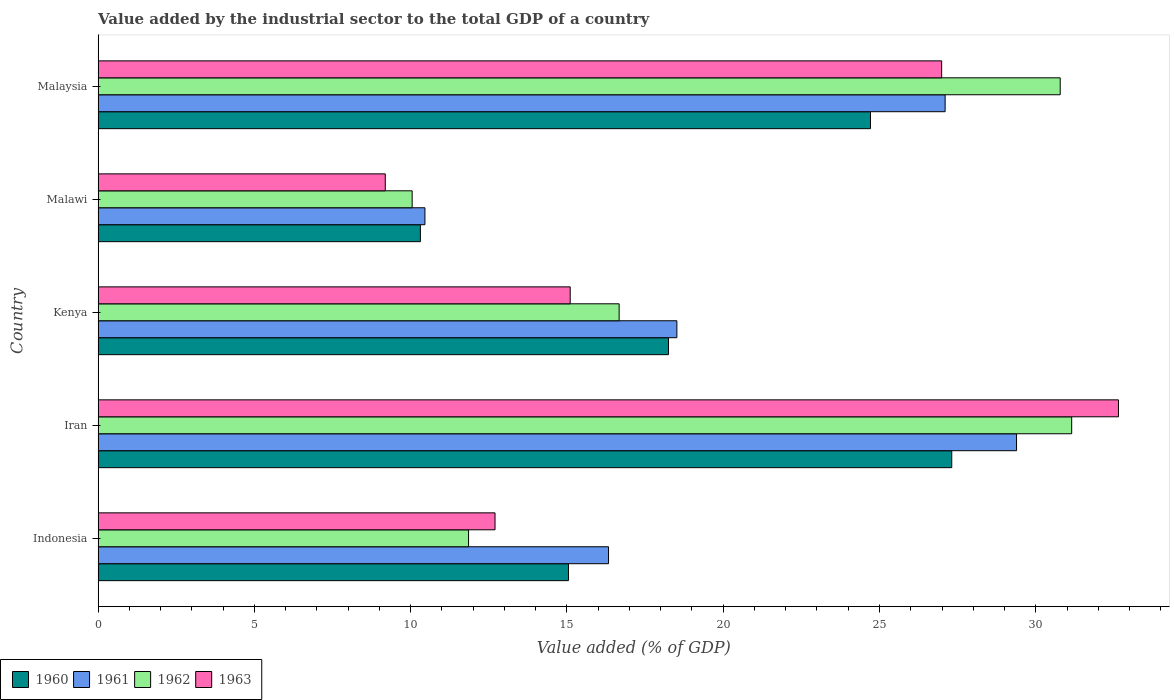How many different coloured bars are there?
Keep it short and to the point. 4. How many groups of bars are there?
Offer a terse response. 5. Are the number of bars on each tick of the Y-axis equal?
Give a very brief answer. Yes. How many bars are there on the 4th tick from the bottom?
Make the answer very short. 4. What is the label of the 1st group of bars from the top?
Keep it short and to the point. Malaysia. What is the value added by the industrial sector to the total GDP in 1960 in Iran?
Offer a terse response. 27.31. Across all countries, what is the maximum value added by the industrial sector to the total GDP in 1962?
Offer a very short reply. 31.15. Across all countries, what is the minimum value added by the industrial sector to the total GDP in 1960?
Keep it short and to the point. 10.31. In which country was the value added by the industrial sector to the total GDP in 1961 maximum?
Make the answer very short. Iran. In which country was the value added by the industrial sector to the total GDP in 1960 minimum?
Offer a very short reply. Malawi. What is the total value added by the industrial sector to the total GDP in 1960 in the graph?
Your answer should be very brief. 95.63. What is the difference between the value added by the industrial sector to the total GDP in 1963 in Iran and that in Malawi?
Offer a terse response. 23.46. What is the difference between the value added by the industrial sector to the total GDP in 1961 in Iran and the value added by the industrial sector to the total GDP in 1962 in Indonesia?
Provide a succinct answer. 17.53. What is the average value added by the industrial sector to the total GDP in 1961 per country?
Your response must be concise. 20.36. What is the difference between the value added by the industrial sector to the total GDP in 1961 and value added by the industrial sector to the total GDP in 1963 in Kenya?
Ensure brevity in your answer.  3.41. In how many countries, is the value added by the industrial sector to the total GDP in 1961 greater than 3 %?
Ensure brevity in your answer.  5. What is the ratio of the value added by the industrial sector to the total GDP in 1961 in Indonesia to that in Kenya?
Give a very brief answer. 0.88. Is the difference between the value added by the industrial sector to the total GDP in 1961 in Malawi and Malaysia greater than the difference between the value added by the industrial sector to the total GDP in 1963 in Malawi and Malaysia?
Make the answer very short. Yes. What is the difference between the highest and the second highest value added by the industrial sector to the total GDP in 1961?
Your answer should be very brief. 2.29. What is the difference between the highest and the lowest value added by the industrial sector to the total GDP in 1960?
Keep it short and to the point. 17. Is the sum of the value added by the industrial sector to the total GDP in 1962 in Indonesia and Iran greater than the maximum value added by the industrial sector to the total GDP in 1960 across all countries?
Ensure brevity in your answer.  Yes. Is it the case that in every country, the sum of the value added by the industrial sector to the total GDP in 1961 and value added by the industrial sector to the total GDP in 1963 is greater than the sum of value added by the industrial sector to the total GDP in 1962 and value added by the industrial sector to the total GDP in 1960?
Ensure brevity in your answer.  No. What does the 3rd bar from the bottom in Malaysia represents?
Provide a succinct answer. 1962. How many countries are there in the graph?
Give a very brief answer. 5. What is the difference between two consecutive major ticks on the X-axis?
Your answer should be compact. 5. Does the graph contain any zero values?
Your answer should be compact. No. How many legend labels are there?
Offer a terse response. 4. How are the legend labels stacked?
Give a very brief answer. Horizontal. What is the title of the graph?
Keep it short and to the point. Value added by the industrial sector to the total GDP of a country. What is the label or title of the X-axis?
Give a very brief answer. Value added (% of GDP). What is the Value added (% of GDP) of 1960 in Indonesia?
Make the answer very short. 15.05. What is the Value added (% of GDP) in 1961 in Indonesia?
Offer a terse response. 16.33. What is the Value added (% of GDP) of 1962 in Indonesia?
Give a very brief answer. 11.85. What is the Value added (% of GDP) in 1963 in Indonesia?
Make the answer very short. 12.7. What is the Value added (% of GDP) in 1960 in Iran?
Provide a succinct answer. 27.31. What is the Value added (% of GDP) of 1961 in Iran?
Your answer should be very brief. 29.38. What is the Value added (% of GDP) in 1962 in Iran?
Your answer should be very brief. 31.15. What is the Value added (% of GDP) of 1963 in Iran?
Provide a short and direct response. 32.65. What is the Value added (% of GDP) of 1960 in Kenya?
Make the answer very short. 18.25. What is the Value added (% of GDP) in 1961 in Kenya?
Your answer should be very brief. 18.52. What is the Value added (% of GDP) of 1962 in Kenya?
Give a very brief answer. 16.67. What is the Value added (% of GDP) of 1963 in Kenya?
Your response must be concise. 15.1. What is the Value added (% of GDP) in 1960 in Malawi?
Provide a short and direct response. 10.31. What is the Value added (% of GDP) of 1961 in Malawi?
Make the answer very short. 10.46. What is the Value added (% of GDP) in 1962 in Malawi?
Offer a very short reply. 10.05. What is the Value added (% of GDP) of 1963 in Malawi?
Offer a terse response. 9.19. What is the Value added (% of GDP) of 1960 in Malaysia?
Your answer should be compact. 24.71. What is the Value added (% of GDP) of 1961 in Malaysia?
Your answer should be very brief. 27.1. What is the Value added (% of GDP) in 1962 in Malaysia?
Your response must be concise. 30.78. What is the Value added (% of GDP) in 1963 in Malaysia?
Your answer should be compact. 26.99. Across all countries, what is the maximum Value added (% of GDP) in 1960?
Give a very brief answer. 27.31. Across all countries, what is the maximum Value added (% of GDP) in 1961?
Your answer should be compact. 29.38. Across all countries, what is the maximum Value added (% of GDP) in 1962?
Your response must be concise. 31.15. Across all countries, what is the maximum Value added (% of GDP) in 1963?
Give a very brief answer. 32.65. Across all countries, what is the minimum Value added (% of GDP) in 1960?
Keep it short and to the point. 10.31. Across all countries, what is the minimum Value added (% of GDP) in 1961?
Offer a very short reply. 10.46. Across all countries, what is the minimum Value added (% of GDP) in 1962?
Offer a terse response. 10.05. Across all countries, what is the minimum Value added (% of GDP) of 1963?
Give a very brief answer. 9.19. What is the total Value added (% of GDP) in 1960 in the graph?
Give a very brief answer. 95.63. What is the total Value added (% of GDP) of 1961 in the graph?
Ensure brevity in your answer.  101.79. What is the total Value added (% of GDP) of 1962 in the graph?
Your response must be concise. 100.5. What is the total Value added (% of GDP) in 1963 in the graph?
Offer a very short reply. 96.63. What is the difference between the Value added (% of GDP) of 1960 in Indonesia and that in Iran?
Give a very brief answer. -12.26. What is the difference between the Value added (% of GDP) of 1961 in Indonesia and that in Iran?
Make the answer very short. -13.05. What is the difference between the Value added (% of GDP) of 1962 in Indonesia and that in Iran?
Provide a succinct answer. -19.3. What is the difference between the Value added (% of GDP) of 1963 in Indonesia and that in Iran?
Offer a terse response. -19.95. What is the difference between the Value added (% of GDP) of 1960 in Indonesia and that in Kenya?
Ensure brevity in your answer.  -3.2. What is the difference between the Value added (% of GDP) in 1961 in Indonesia and that in Kenya?
Your response must be concise. -2.19. What is the difference between the Value added (% of GDP) of 1962 in Indonesia and that in Kenya?
Your response must be concise. -4.82. What is the difference between the Value added (% of GDP) of 1963 in Indonesia and that in Kenya?
Offer a very short reply. -2.4. What is the difference between the Value added (% of GDP) in 1960 in Indonesia and that in Malawi?
Your answer should be compact. 4.74. What is the difference between the Value added (% of GDP) in 1961 in Indonesia and that in Malawi?
Provide a succinct answer. 5.87. What is the difference between the Value added (% of GDP) in 1962 in Indonesia and that in Malawi?
Your answer should be compact. 1.8. What is the difference between the Value added (% of GDP) in 1963 in Indonesia and that in Malawi?
Make the answer very short. 3.51. What is the difference between the Value added (% of GDP) in 1960 in Indonesia and that in Malaysia?
Make the answer very short. -9.66. What is the difference between the Value added (% of GDP) in 1961 in Indonesia and that in Malaysia?
Your response must be concise. -10.77. What is the difference between the Value added (% of GDP) of 1962 in Indonesia and that in Malaysia?
Your answer should be compact. -18.93. What is the difference between the Value added (% of GDP) of 1963 in Indonesia and that in Malaysia?
Give a very brief answer. -14.29. What is the difference between the Value added (% of GDP) of 1960 in Iran and that in Kenya?
Offer a very short reply. 9.06. What is the difference between the Value added (% of GDP) of 1961 in Iran and that in Kenya?
Your answer should be very brief. 10.87. What is the difference between the Value added (% of GDP) in 1962 in Iran and that in Kenya?
Give a very brief answer. 14.48. What is the difference between the Value added (% of GDP) in 1963 in Iran and that in Kenya?
Keep it short and to the point. 17.54. What is the difference between the Value added (% of GDP) of 1960 in Iran and that in Malawi?
Offer a very short reply. 17. What is the difference between the Value added (% of GDP) in 1961 in Iran and that in Malawi?
Your response must be concise. 18.93. What is the difference between the Value added (% of GDP) of 1962 in Iran and that in Malawi?
Give a very brief answer. 21.1. What is the difference between the Value added (% of GDP) of 1963 in Iran and that in Malawi?
Make the answer very short. 23.46. What is the difference between the Value added (% of GDP) in 1960 in Iran and that in Malaysia?
Provide a succinct answer. 2.6. What is the difference between the Value added (% of GDP) of 1961 in Iran and that in Malaysia?
Give a very brief answer. 2.29. What is the difference between the Value added (% of GDP) in 1962 in Iran and that in Malaysia?
Provide a succinct answer. 0.37. What is the difference between the Value added (% of GDP) in 1963 in Iran and that in Malaysia?
Your answer should be very brief. 5.66. What is the difference between the Value added (% of GDP) in 1960 in Kenya and that in Malawi?
Offer a terse response. 7.94. What is the difference between the Value added (% of GDP) of 1961 in Kenya and that in Malawi?
Ensure brevity in your answer.  8.06. What is the difference between the Value added (% of GDP) in 1962 in Kenya and that in Malawi?
Provide a short and direct response. 6.62. What is the difference between the Value added (% of GDP) in 1963 in Kenya and that in Malawi?
Your answer should be compact. 5.92. What is the difference between the Value added (% of GDP) in 1960 in Kenya and that in Malaysia?
Your response must be concise. -6.46. What is the difference between the Value added (% of GDP) in 1961 in Kenya and that in Malaysia?
Provide a short and direct response. -8.58. What is the difference between the Value added (% of GDP) of 1962 in Kenya and that in Malaysia?
Provide a succinct answer. -14.11. What is the difference between the Value added (% of GDP) of 1963 in Kenya and that in Malaysia?
Your response must be concise. -11.88. What is the difference between the Value added (% of GDP) in 1960 in Malawi and that in Malaysia?
Your response must be concise. -14.4. What is the difference between the Value added (% of GDP) in 1961 in Malawi and that in Malaysia?
Keep it short and to the point. -16.64. What is the difference between the Value added (% of GDP) in 1962 in Malawi and that in Malaysia?
Provide a short and direct response. -20.73. What is the difference between the Value added (% of GDP) of 1963 in Malawi and that in Malaysia?
Ensure brevity in your answer.  -17.8. What is the difference between the Value added (% of GDP) in 1960 in Indonesia and the Value added (% of GDP) in 1961 in Iran?
Keep it short and to the point. -14.34. What is the difference between the Value added (% of GDP) in 1960 in Indonesia and the Value added (% of GDP) in 1962 in Iran?
Keep it short and to the point. -16.1. What is the difference between the Value added (% of GDP) of 1960 in Indonesia and the Value added (% of GDP) of 1963 in Iran?
Your answer should be very brief. -17.6. What is the difference between the Value added (% of GDP) in 1961 in Indonesia and the Value added (% of GDP) in 1962 in Iran?
Offer a terse response. -14.82. What is the difference between the Value added (% of GDP) in 1961 in Indonesia and the Value added (% of GDP) in 1963 in Iran?
Your answer should be very brief. -16.32. What is the difference between the Value added (% of GDP) of 1962 in Indonesia and the Value added (% of GDP) of 1963 in Iran?
Make the answer very short. -20.79. What is the difference between the Value added (% of GDP) of 1960 in Indonesia and the Value added (% of GDP) of 1961 in Kenya?
Your answer should be compact. -3.47. What is the difference between the Value added (% of GDP) of 1960 in Indonesia and the Value added (% of GDP) of 1962 in Kenya?
Provide a succinct answer. -1.62. What is the difference between the Value added (% of GDP) of 1960 in Indonesia and the Value added (% of GDP) of 1963 in Kenya?
Give a very brief answer. -0.06. What is the difference between the Value added (% of GDP) in 1961 in Indonesia and the Value added (% of GDP) in 1962 in Kenya?
Give a very brief answer. -0.34. What is the difference between the Value added (% of GDP) in 1961 in Indonesia and the Value added (% of GDP) in 1963 in Kenya?
Your answer should be compact. 1.23. What is the difference between the Value added (% of GDP) of 1962 in Indonesia and the Value added (% of GDP) of 1963 in Kenya?
Ensure brevity in your answer.  -3.25. What is the difference between the Value added (% of GDP) of 1960 in Indonesia and the Value added (% of GDP) of 1961 in Malawi?
Give a very brief answer. 4.59. What is the difference between the Value added (% of GDP) in 1960 in Indonesia and the Value added (% of GDP) in 1962 in Malawi?
Your response must be concise. 5. What is the difference between the Value added (% of GDP) in 1960 in Indonesia and the Value added (% of GDP) in 1963 in Malawi?
Make the answer very short. 5.86. What is the difference between the Value added (% of GDP) in 1961 in Indonesia and the Value added (% of GDP) in 1962 in Malawi?
Keep it short and to the point. 6.28. What is the difference between the Value added (% of GDP) of 1961 in Indonesia and the Value added (% of GDP) of 1963 in Malawi?
Give a very brief answer. 7.14. What is the difference between the Value added (% of GDP) of 1962 in Indonesia and the Value added (% of GDP) of 1963 in Malawi?
Ensure brevity in your answer.  2.66. What is the difference between the Value added (% of GDP) of 1960 in Indonesia and the Value added (% of GDP) of 1961 in Malaysia?
Your answer should be compact. -12.05. What is the difference between the Value added (% of GDP) of 1960 in Indonesia and the Value added (% of GDP) of 1962 in Malaysia?
Offer a very short reply. -15.73. What is the difference between the Value added (% of GDP) of 1960 in Indonesia and the Value added (% of GDP) of 1963 in Malaysia?
Your response must be concise. -11.94. What is the difference between the Value added (% of GDP) in 1961 in Indonesia and the Value added (% of GDP) in 1962 in Malaysia?
Offer a very short reply. -14.45. What is the difference between the Value added (% of GDP) of 1961 in Indonesia and the Value added (% of GDP) of 1963 in Malaysia?
Your response must be concise. -10.66. What is the difference between the Value added (% of GDP) of 1962 in Indonesia and the Value added (% of GDP) of 1963 in Malaysia?
Provide a succinct answer. -15.14. What is the difference between the Value added (% of GDP) in 1960 in Iran and the Value added (% of GDP) in 1961 in Kenya?
Give a very brief answer. 8.79. What is the difference between the Value added (% of GDP) in 1960 in Iran and the Value added (% of GDP) in 1962 in Kenya?
Your response must be concise. 10.64. What is the difference between the Value added (% of GDP) in 1960 in Iran and the Value added (% of GDP) in 1963 in Kenya?
Give a very brief answer. 12.21. What is the difference between the Value added (% of GDP) in 1961 in Iran and the Value added (% of GDP) in 1962 in Kenya?
Keep it short and to the point. 12.71. What is the difference between the Value added (% of GDP) in 1961 in Iran and the Value added (% of GDP) in 1963 in Kenya?
Keep it short and to the point. 14.28. What is the difference between the Value added (% of GDP) of 1962 in Iran and the Value added (% of GDP) of 1963 in Kenya?
Make the answer very short. 16.04. What is the difference between the Value added (% of GDP) of 1960 in Iran and the Value added (% of GDP) of 1961 in Malawi?
Your response must be concise. 16.86. What is the difference between the Value added (% of GDP) of 1960 in Iran and the Value added (% of GDP) of 1962 in Malawi?
Keep it short and to the point. 17.26. What is the difference between the Value added (% of GDP) in 1960 in Iran and the Value added (% of GDP) in 1963 in Malawi?
Provide a succinct answer. 18.12. What is the difference between the Value added (% of GDP) in 1961 in Iran and the Value added (% of GDP) in 1962 in Malawi?
Provide a succinct answer. 19.34. What is the difference between the Value added (% of GDP) in 1961 in Iran and the Value added (% of GDP) in 1963 in Malawi?
Make the answer very short. 20.2. What is the difference between the Value added (% of GDP) of 1962 in Iran and the Value added (% of GDP) of 1963 in Malawi?
Keep it short and to the point. 21.96. What is the difference between the Value added (% of GDP) of 1960 in Iran and the Value added (% of GDP) of 1961 in Malaysia?
Provide a short and direct response. 0.21. What is the difference between the Value added (% of GDP) of 1960 in Iran and the Value added (% of GDP) of 1962 in Malaysia?
Give a very brief answer. -3.47. What is the difference between the Value added (% of GDP) in 1960 in Iran and the Value added (% of GDP) in 1963 in Malaysia?
Your answer should be compact. 0.32. What is the difference between the Value added (% of GDP) in 1961 in Iran and the Value added (% of GDP) in 1962 in Malaysia?
Offer a very short reply. -1.4. What is the difference between the Value added (% of GDP) in 1961 in Iran and the Value added (% of GDP) in 1963 in Malaysia?
Your answer should be very brief. 2.4. What is the difference between the Value added (% of GDP) in 1962 in Iran and the Value added (% of GDP) in 1963 in Malaysia?
Your answer should be very brief. 4.16. What is the difference between the Value added (% of GDP) in 1960 in Kenya and the Value added (% of GDP) in 1961 in Malawi?
Your answer should be very brief. 7.79. What is the difference between the Value added (% of GDP) of 1960 in Kenya and the Value added (% of GDP) of 1962 in Malawi?
Make the answer very short. 8.2. What is the difference between the Value added (% of GDP) in 1960 in Kenya and the Value added (% of GDP) in 1963 in Malawi?
Your answer should be compact. 9.06. What is the difference between the Value added (% of GDP) in 1961 in Kenya and the Value added (% of GDP) in 1962 in Malawi?
Ensure brevity in your answer.  8.47. What is the difference between the Value added (% of GDP) in 1961 in Kenya and the Value added (% of GDP) in 1963 in Malawi?
Your answer should be very brief. 9.33. What is the difference between the Value added (% of GDP) in 1962 in Kenya and the Value added (% of GDP) in 1963 in Malawi?
Offer a terse response. 7.48. What is the difference between the Value added (% of GDP) in 1960 in Kenya and the Value added (% of GDP) in 1961 in Malaysia?
Your answer should be compact. -8.85. What is the difference between the Value added (% of GDP) of 1960 in Kenya and the Value added (% of GDP) of 1962 in Malaysia?
Offer a very short reply. -12.53. What is the difference between the Value added (% of GDP) of 1960 in Kenya and the Value added (% of GDP) of 1963 in Malaysia?
Offer a terse response. -8.74. What is the difference between the Value added (% of GDP) in 1961 in Kenya and the Value added (% of GDP) in 1962 in Malaysia?
Offer a very short reply. -12.26. What is the difference between the Value added (% of GDP) in 1961 in Kenya and the Value added (% of GDP) in 1963 in Malaysia?
Offer a very short reply. -8.47. What is the difference between the Value added (% of GDP) in 1962 in Kenya and the Value added (% of GDP) in 1963 in Malaysia?
Your answer should be compact. -10.32. What is the difference between the Value added (% of GDP) of 1960 in Malawi and the Value added (% of GDP) of 1961 in Malaysia?
Offer a very short reply. -16.79. What is the difference between the Value added (% of GDP) in 1960 in Malawi and the Value added (% of GDP) in 1962 in Malaysia?
Provide a short and direct response. -20.47. What is the difference between the Value added (% of GDP) of 1960 in Malawi and the Value added (% of GDP) of 1963 in Malaysia?
Your answer should be very brief. -16.68. What is the difference between the Value added (% of GDP) in 1961 in Malawi and the Value added (% of GDP) in 1962 in Malaysia?
Provide a short and direct response. -20.33. What is the difference between the Value added (% of GDP) of 1961 in Malawi and the Value added (% of GDP) of 1963 in Malaysia?
Your answer should be compact. -16.53. What is the difference between the Value added (% of GDP) of 1962 in Malawi and the Value added (% of GDP) of 1963 in Malaysia?
Make the answer very short. -16.94. What is the average Value added (% of GDP) in 1960 per country?
Provide a succinct answer. 19.13. What is the average Value added (% of GDP) in 1961 per country?
Ensure brevity in your answer.  20.36. What is the average Value added (% of GDP) of 1962 per country?
Keep it short and to the point. 20.1. What is the average Value added (% of GDP) of 1963 per country?
Your answer should be very brief. 19.33. What is the difference between the Value added (% of GDP) of 1960 and Value added (% of GDP) of 1961 in Indonesia?
Ensure brevity in your answer.  -1.28. What is the difference between the Value added (% of GDP) in 1960 and Value added (% of GDP) in 1962 in Indonesia?
Provide a succinct answer. 3.2. What is the difference between the Value added (% of GDP) of 1960 and Value added (% of GDP) of 1963 in Indonesia?
Make the answer very short. 2.35. What is the difference between the Value added (% of GDP) in 1961 and Value added (% of GDP) in 1962 in Indonesia?
Your answer should be very brief. 4.48. What is the difference between the Value added (% of GDP) in 1961 and Value added (% of GDP) in 1963 in Indonesia?
Keep it short and to the point. 3.63. What is the difference between the Value added (% of GDP) in 1962 and Value added (% of GDP) in 1963 in Indonesia?
Your answer should be very brief. -0.85. What is the difference between the Value added (% of GDP) of 1960 and Value added (% of GDP) of 1961 in Iran?
Your answer should be very brief. -2.07. What is the difference between the Value added (% of GDP) of 1960 and Value added (% of GDP) of 1962 in Iran?
Your answer should be very brief. -3.84. What is the difference between the Value added (% of GDP) of 1960 and Value added (% of GDP) of 1963 in Iran?
Give a very brief answer. -5.33. What is the difference between the Value added (% of GDP) of 1961 and Value added (% of GDP) of 1962 in Iran?
Offer a terse response. -1.76. What is the difference between the Value added (% of GDP) of 1961 and Value added (% of GDP) of 1963 in Iran?
Offer a very short reply. -3.26. What is the difference between the Value added (% of GDP) in 1962 and Value added (% of GDP) in 1963 in Iran?
Your answer should be compact. -1.5. What is the difference between the Value added (% of GDP) in 1960 and Value added (% of GDP) in 1961 in Kenya?
Make the answer very short. -0.27. What is the difference between the Value added (% of GDP) in 1960 and Value added (% of GDP) in 1962 in Kenya?
Provide a short and direct response. 1.58. What is the difference between the Value added (% of GDP) of 1960 and Value added (% of GDP) of 1963 in Kenya?
Ensure brevity in your answer.  3.14. What is the difference between the Value added (% of GDP) of 1961 and Value added (% of GDP) of 1962 in Kenya?
Your answer should be very brief. 1.85. What is the difference between the Value added (% of GDP) in 1961 and Value added (% of GDP) in 1963 in Kenya?
Ensure brevity in your answer.  3.41. What is the difference between the Value added (% of GDP) of 1962 and Value added (% of GDP) of 1963 in Kenya?
Keep it short and to the point. 1.57. What is the difference between the Value added (% of GDP) in 1960 and Value added (% of GDP) in 1961 in Malawi?
Ensure brevity in your answer.  -0.15. What is the difference between the Value added (% of GDP) in 1960 and Value added (% of GDP) in 1962 in Malawi?
Offer a very short reply. 0.26. What is the difference between the Value added (% of GDP) of 1960 and Value added (% of GDP) of 1963 in Malawi?
Give a very brief answer. 1.12. What is the difference between the Value added (% of GDP) of 1961 and Value added (% of GDP) of 1962 in Malawi?
Offer a terse response. 0.41. What is the difference between the Value added (% of GDP) of 1961 and Value added (% of GDP) of 1963 in Malawi?
Provide a succinct answer. 1.27. What is the difference between the Value added (% of GDP) in 1962 and Value added (% of GDP) in 1963 in Malawi?
Make the answer very short. 0.86. What is the difference between the Value added (% of GDP) in 1960 and Value added (% of GDP) in 1961 in Malaysia?
Provide a succinct answer. -2.39. What is the difference between the Value added (% of GDP) in 1960 and Value added (% of GDP) in 1962 in Malaysia?
Give a very brief answer. -6.07. What is the difference between the Value added (% of GDP) of 1960 and Value added (% of GDP) of 1963 in Malaysia?
Offer a terse response. -2.28. What is the difference between the Value added (% of GDP) of 1961 and Value added (% of GDP) of 1962 in Malaysia?
Offer a terse response. -3.68. What is the difference between the Value added (% of GDP) of 1961 and Value added (% of GDP) of 1963 in Malaysia?
Offer a very short reply. 0.11. What is the difference between the Value added (% of GDP) in 1962 and Value added (% of GDP) in 1963 in Malaysia?
Your answer should be compact. 3.79. What is the ratio of the Value added (% of GDP) of 1960 in Indonesia to that in Iran?
Your answer should be compact. 0.55. What is the ratio of the Value added (% of GDP) in 1961 in Indonesia to that in Iran?
Your answer should be very brief. 0.56. What is the ratio of the Value added (% of GDP) in 1962 in Indonesia to that in Iran?
Provide a succinct answer. 0.38. What is the ratio of the Value added (% of GDP) in 1963 in Indonesia to that in Iran?
Your answer should be very brief. 0.39. What is the ratio of the Value added (% of GDP) of 1960 in Indonesia to that in Kenya?
Offer a terse response. 0.82. What is the ratio of the Value added (% of GDP) of 1961 in Indonesia to that in Kenya?
Your answer should be compact. 0.88. What is the ratio of the Value added (% of GDP) of 1962 in Indonesia to that in Kenya?
Give a very brief answer. 0.71. What is the ratio of the Value added (% of GDP) in 1963 in Indonesia to that in Kenya?
Keep it short and to the point. 0.84. What is the ratio of the Value added (% of GDP) of 1960 in Indonesia to that in Malawi?
Provide a short and direct response. 1.46. What is the ratio of the Value added (% of GDP) in 1961 in Indonesia to that in Malawi?
Make the answer very short. 1.56. What is the ratio of the Value added (% of GDP) of 1962 in Indonesia to that in Malawi?
Ensure brevity in your answer.  1.18. What is the ratio of the Value added (% of GDP) in 1963 in Indonesia to that in Malawi?
Ensure brevity in your answer.  1.38. What is the ratio of the Value added (% of GDP) in 1960 in Indonesia to that in Malaysia?
Give a very brief answer. 0.61. What is the ratio of the Value added (% of GDP) in 1961 in Indonesia to that in Malaysia?
Give a very brief answer. 0.6. What is the ratio of the Value added (% of GDP) in 1962 in Indonesia to that in Malaysia?
Make the answer very short. 0.39. What is the ratio of the Value added (% of GDP) in 1963 in Indonesia to that in Malaysia?
Provide a short and direct response. 0.47. What is the ratio of the Value added (% of GDP) in 1960 in Iran to that in Kenya?
Your response must be concise. 1.5. What is the ratio of the Value added (% of GDP) in 1961 in Iran to that in Kenya?
Keep it short and to the point. 1.59. What is the ratio of the Value added (% of GDP) in 1962 in Iran to that in Kenya?
Make the answer very short. 1.87. What is the ratio of the Value added (% of GDP) in 1963 in Iran to that in Kenya?
Ensure brevity in your answer.  2.16. What is the ratio of the Value added (% of GDP) in 1960 in Iran to that in Malawi?
Keep it short and to the point. 2.65. What is the ratio of the Value added (% of GDP) of 1961 in Iran to that in Malawi?
Your answer should be very brief. 2.81. What is the ratio of the Value added (% of GDP) of 1962 in Iran to that in Malawi?
Your answer should be compact. 3.1. What is the ratio of the Value added (% of GDP) of 1963 in Iran to that in Malawi?
Make the answer very short. 3.55. What is the ratio of the Value added (% of GDP) in 1960 in Iran to that in Malaysia?
Offer a very short reply. 1.11. What is the ratio of the Value added (% of GDP) in 1961 in Iran to that in Malaysia?
Your response must be concise. 1.08. What is the ratio of the Value added (% of GDP) of 1962 in Iran to that in Malaysia?
Ensure brevity in your answer.  1.01. What is the ratio of the Value added (% of GDP) in 1963 in Iran to that in Malaysia?
Provide a succinct answer. 1.21. What is the ratio of the Value added (% of GDP) in 1960 in Kenya to that in Malawi?
Your answer should be compact. 1.77. What is the ratio of the Value added (% of GDP) in 1961 in Kenya to that in Malawi?
Your answer should be very brief. 1.77. What is the ratio of the Value added (% of GDP) in 1962 in Kenya to that in Malawi?
Provide a short and direct response. 1.66. What is the ratio of the Value added (% of GDP) of 1963 in Kenya to that in Malawi?
Your answer should be compact. 1.64. What is the ratio of the Value added (% of GDP) in 1960 in Kenya to that in Malaysia?
Keep it short and to the point. 0.74. What is the ratio of the Value added (% of GDP) in 1961 in Kenya to that in Malaysia?
Your answer should be compact. 0.68. What is the ratio of the Value added (% of GDP) in 1962 in Kenya to that in Malaysia?
Your response must be concise. 0.54. What is the ratio of the Value added (% of GDP) in 1963 in Kenya to that in Malaysia?
Ensure brevity in your answer.  0.56. What is the ratio of the Value added (% of GDP) in 1960 in Malawi to that in Malaysia?
Your response must be concise. 0.42. What is the ratio of the Value added (% of GDP) in 1961 in Malawi to that in Malaysia?
Make the answer very short. 0.39. What is the ratio of the Value added (% of GDP) in 1962 in Malawi to that in Malaysia?
Ensure brevity in your answer.  0.33. What is the ratio of the Value added (% of GDP) in 1963 in Malawi to that in Malaysia?
Offer a very short reply. 0.34. What is the difference between the highest and the second highest Value added (% of GDP) of 1960?
Your response must be concise. 2.6. What is the difference between the highest and the second highest Value added (% of GDP) in 1961?
Your response must be concise. 2.29. What is the difference between the highest and the second highest Value added (% of GDP) in 1962?
Provide a succinct answer. 0.37. What is the difference between the highest and the second highest Value added (% of GDP) in 1963?
Offer a terse response. 5.66. What is the difference between the highest and the lowest Value added (% of GDP) of 1960?
Offer a very short reply. 17. What is the difference between the highest and the lowest Value added (% of GDP) in 1961?
Provide a short and direct response. 18.93. What is the difference between the highest and the lowest Value added (% of GDP) of 1962?
Offer a very short reply. 21.1. What is the difference between the highest and the lowest Value added (% of GDP) of 1963?
Provide a succinct answer. 23.46. 